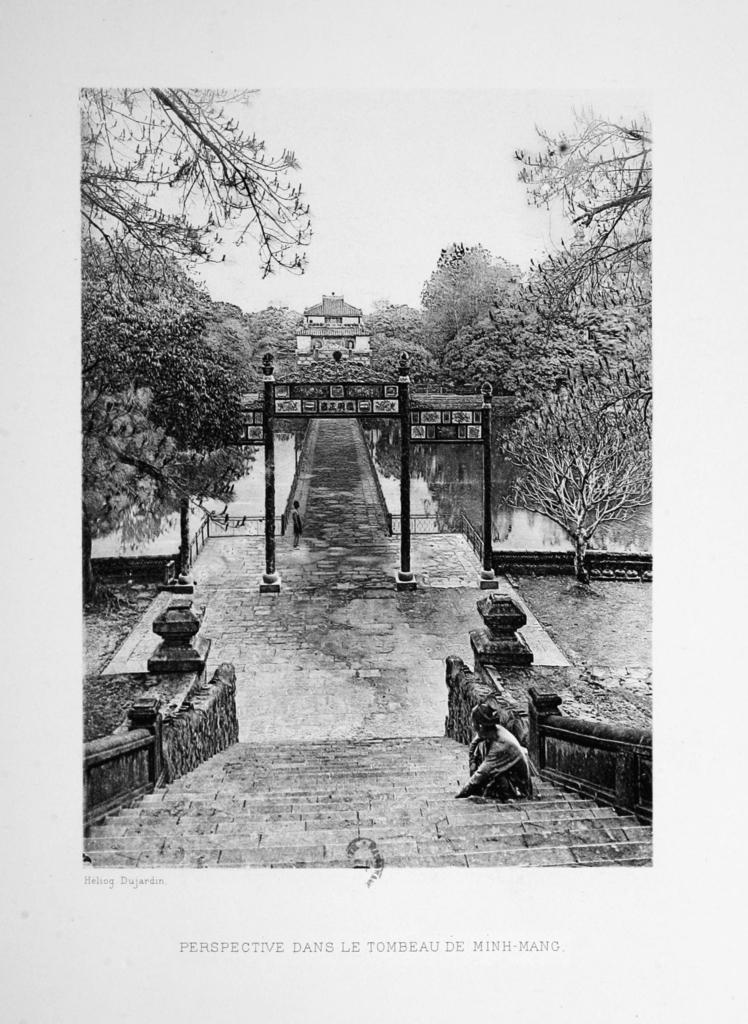Can you describe this image briefly? This is a black and white picture. On this poster we can see a person, poles, boards, and trees. This is water. In the background there is sky. 